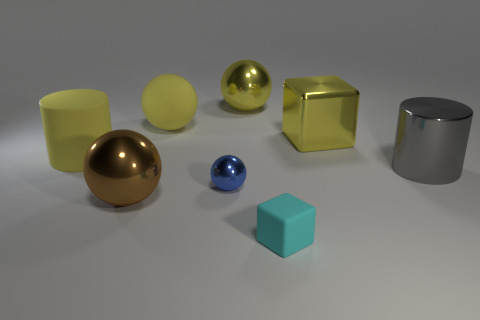Subtract all cyan cubes. How many yellow spheres are left? 2 Subtract all brown spheres. How many spheres are left? 3 Subtract all tiny blue balls. How many balls are left? 3 Subtract all purple spheres. Subtract all purple cylinders. How many spheres are left? 4 Subtract all cylinders. How many objects are left? 6 Subtract 0 blue blocks. How many objects are left? 8 Subtract all tiny cyan rubber blocks. Subtract all large rubber objects. How many objects are left? 5 Add 5 small cyan cubes. How many small cyan cubes are left? 6 Add 1 green rubber things. How many green rubber things exist? 1 